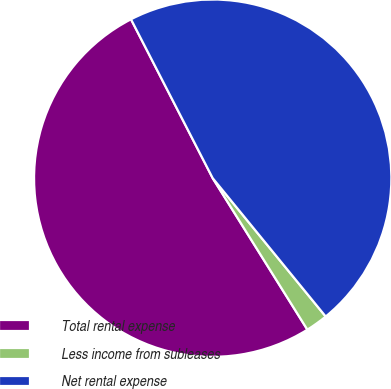Convert chart. <chart><loc_0><loc_0><loc_500><loc_500><pie_chart><fcel>Total rental expense<fcel>Less income from subleases<fcel>Net rental expense<nl><fcel>51.33%<fcel>2.01%<fcel>46.66%<nl></chart> 